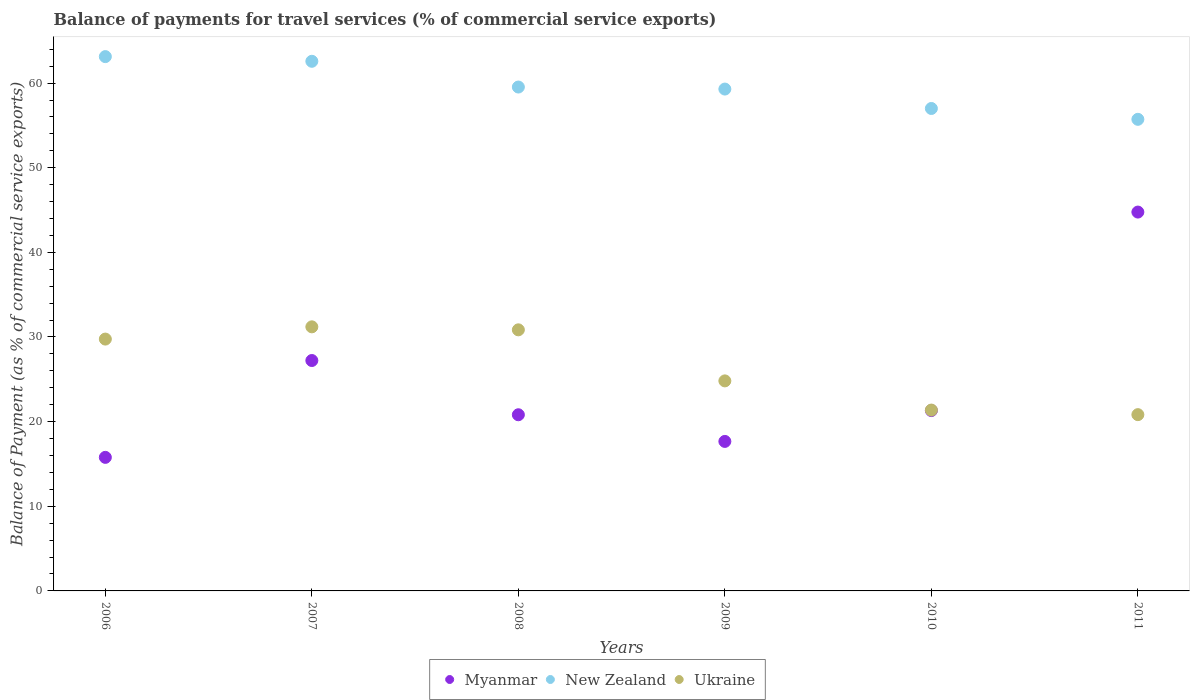Is the number of dotlines equal to the number of legend labels?
Offer a very short reply. Yes. What is the balance of payments for travel services in Myanmar in 2009?
Provide a short and direct response. 17.66. Across all years, what is the maximum balance of payments for travel services in New Zealand?
Provide a short and direct response. 63.13. Across all years, what is the minimum balance of payments for travel services in New Zealand?
Provide a succinct answer. 55.72. In which year was the balance of payments for travel services in Ukraine maximum?
Offer a terse response. 2007. In which year was the balance of payments for travel services in Myanmar minimum?
Provide a succinct answer. 2006. What is the total balance of payments for travel services in Ukraine in the graph?
Provide a short and direct response. 158.81. What is the difference between the balance of payments for travel services in Ukraine in 2007 and that in 2011?
Your answer should be compact. 10.37. What is the difference between the balance of payments for travel services in New Zealand in 2011 and the balance of payments for travel services in Myanmar in 2009?
Offer a terse response. 38.05. What is the average balance of payments for travel services in New Zealand per year?
Keep it short and to the point. 59.54. In the year 2008, what is the difference between the balance of payments for travel services in Ukraine and balance of payments for travel services in New Zealand?
Your response must be concise. -28.69. What is the ratio of the balance of payments for travel services in Myanmar in 2006 to that in 2010?
Your answer should be very brief. 0.74. Is the balance of payments for travel services in Myanmar in 2008 less than that in 2009?
Offer a very short reply. No. What is the difference between the highest and the second highest balance of payments for travel services in New Zealand?
Provide a succinct answer. 0.55. What is the difference between the highest and the lowest balance of payments for travel services in New Zealand?
Your response must be concise. 7.41. In how many years, is the balance of payments for travel services in Ukraine greater than the average balance of payments for travel services in Ukraine taken over all years?
Provide a short and direct response. 3. Is the sum of the balance of payments for travel services in Myanmar in 2008 and 2010 greater than the maximum balance of payments for travel services in Ukraine across all years?
Ensure brevity in your answer.  Yes. Is it the case that in every year, the sum of the balance of payments for travel services in Myanmar and balance of payments for travel services in New Zealand  is greater than the balance of payments for travel services in Ukraine?
Give a very brief answer. Yes. Does the balance of payments for travel services in Ukraine monotonically increase over the years?
Offer a terse response. No. Is the balance of payments for travel services in Myanmar strictly greater than the balance of payments for travel services in Ukraine over the years?
Ensure brevity in your answer.  No. How many dotlines are there?
Your response must be concise. 3. Does the graph contain any zero values?
Keep it short and to the point. No. Does the graph contain grids?
Offer a very short reply. No. Where does the legend appear in the graph?
Make the answer very short. Bottom center. How are the legend labels stacked?
Ensure brevity in your answer.  Horizontal. What is the title of the graph?
Make the answer very short. Balance of payments for travel services (% of commercial service exports). What is the label or title of the X-axis?
Provide a short and direct response. Years. What is the label or title of the Y-axis?
Ensure brevity in your answer.  Balance of Payment (as % of commercial service exports). What is the Balance of Payment (as % of commercial service exports) of Myanmar in 2006?
Keep it short and to the point. 15.78. What is the Balance of Payment (as % of commercial service exports) in New Zealand in 2006?
Provide a succinct answer. 63.13. What is the Balance of Payment (as % of commercial service exports) of Ukraine in 2006?
Provide a short and direct response. 29.75. What is the Balance of Payment (as % of commercial service exports) in Myanmar in 2007?
Provide a succinct answer. 27.22. What is the Balance of Payment (as % of commercial service exports) in New Zealand in 2007?
Your answer should be compact. 62.57. What is the Balance of Payment (as % of commercial service exports) of Ukraine in 2007?
Your answer should be very brief. 31.2. What is the Balance of Payment (as % of commercial service exports) of Myanmar in 2008?
Give a very brief answer. 20.81. What is the Balance of Payment (as % of commercial service exports) of New Zealand in 2008?
Offer a terse response. 59.53. What is the Balance of Payment (as % of commercial service exports) in Ukraine in 2008?
Your answer should be very brief. 30.85. What is the Balance of Payment (as % of commercial service exports) in Myanmar in 2009?
Make the answer very short. 17.66. What is the Balance of Payment (as % of commercial service exports) in New Zealand in 2009?
Provide a short and direct response. 59.29. What is the Balance of Payment (as % of commercial service exports) of Ukraine in 2009?
Your response must be concise. 24.81. What is the Balance of Payment (as % of commercial service exports) in Myanmar in 2010?
Ensure brevity in your answer.  21.31. What is the Balance of Payment (as % of commercial service exports) of New Zealand in 2010?
Offer a very short reply. 57. What is the Balance of Payment (as % of commercial service exports) of Ukraine in 2010?
Ensure brevity in your answer.  21.37. What is the Balance of Payment (as % of commercial service exports) in Myanmar in 2011?
Ensure brevity in your answer.  44.76. What is the Balance of Payment (as % of commercial service exports) in New Zealand in 2011?
Your response must be concise. 55.72. What is the Balance of Payment (as % of commercial service exports) of Ukraine in 2011?
Provide a short and direct response. 20.83. Across all years, what is the maximum Balance of Payment (as % of commercial service exports) of Myanmar?
Provide a succinct answer. 44.76. Across all years, what is the maximum Balance of Payment (as % of commercial service exports) of New Zealand?
Your answer should be very brief. 63.13. Across all years, what is the maximum Balance of Payment (as % of commercial service exports) in Ukraine?
Offer a very short reply. 31.2. Across all years, what is the minimum Balance of Payment (as % of commercial service exports) in Myanmar?
Your response must be concise. 15.78. Across all years, what is the minimum Balance of Payment (as % of commercial service exports) of New Zealand?
Provide a short and direct response. 55.72. Across all years, what is the minimum Balance of Payment (as % of commercial service exports) of Ukraine?
Provide a succinct answer. 20.83. What is the total Balance of Payment (as % of commercial service exports) of Myanmar in the graph?
Give a very brief answer. 147.54. What is the total Balance of Payment (as % of commercial service exports) in New Zealand in the graph?
Give a very brief answer. 357.24. What is the total Balance of Payment (as % of commercial service exports) in Ukraine in the graph?
Ensure brevity in your answer.  158.81. What is the difference between the Balance of Payment (as % of commercial service exports) in Myanmar in 2006 and that in 2007?
Your answer should be very brief. -11.44. What is the difference between the Balance of Payment (as % of commercial service exports) in New Zealand in 2006 and that in 2007?
Your response must be concise. 0.55. What is the difference between the Balance of Payment (as % of commercial service exports) of Ukraine in 2006 and that in 2007?
Your answer should be compact. -1.45. What is the difference between the Balance of Payment (as % of commercial service exports) in Myanmar in 2006 and that in 2008?
Your response must be concise. -5.03. What is the difference between the Balance of Payment (as % of commercial service exports) in New Zealand in 2006 and that in 2008?
Give a very brief answer. 3.59. What is the difference between the Balance of Payment (as % of commercial service exports) of Ukraine in 2006 and that in 2008?
Ensure brevity in your answer.  -1.09. What is the difference between the Balance of Payment (as % of commercial service exports) in Myanmar in 2006 and that in 2009?
Offer a terse response. -1.88. What is the difference between the Balance of Payment (as % of commercial service exports) of New Zealand in 2006 and that in 2009?
Ensure brevity in your answer.  3.83. What is the difference between the Balance of Payment (as % of commercial service exports) of Ukraine in 2006 and that in 2009?
Ensure brevity in your answer.  4.94. What is the difference between the Balance of Payment (as % of commercial service exports) of Myanmar in 2006 and that in 2010?
Give a very brief answer. -5.53. What is the difference between the Balance of Payment (as % of commercial service exports) of New Zealand in 2006 and that in 2010?
Keep it short and to the point. 6.13. What is the difference between the Balance of Payment (as % of commercial service exports) in Ukraine in 2006 and that in 2010?
Provide a succinct answer. 8.39. What is the difference between the Balance of Payment (as % of commercial service exports) in Myanmar in 2006 and that in 2011?
Ensure brevity in your answer.  -28.98. What is the difference between the Balance of Payment (as % of commercial service exports) in New Zealand in 2006 and that in 2011?
Give a very brief answer. 7.41. What is the difference between the Balance of Payment (as % of commercial service exports) in Ukraine in 2006 and that in 2011?
Your answer should be compact. 8.93. What is the difference between the Balance of Payment (as % of commercial service exports) of Myanmar in 2007 and that in 2008?
Give a very brief answer. 6.41. What is the difference between the Balance of Payment (as % of commercial service exports) in New Zealand in 2007 and that in 2008?
Your answer should be compact. 3.04. What is the difference between the Balance of Payment (as % of commercial service exports) of Ukraine in 2007 and that in 2008?
Offer a terse response. 0.35. What is the difference between the Balance of Payment (as % of commercial service exports) of Myanmar in 2007 and that in 2009?
Give a very brief answer. 9.56. What is the difference between the Balance of Payment (as % of commercial service exports) in New Zealand in 2007 and that in 2009?
Make the answer very short. 3.28. What is the difference between the Balance of Payment (as % of commercial service exports) in Ukraine in 2007 and that in 2009?
Offer a terse response. 6.39. What is the difference between the Balance of Payment (as % of commercial service exports) of Myanmar in 2007 and that in 2010?
Offer a very short reply. 5.91. What is the difference between the Balance of Payment (as % of commercial service exports) in New Zealand in 2007 and that in 2010?
Make the answer very short. 5.57. What is the difference between the Balance of Payment (as % of commercial service exports) in Ukraine in 2007 and that in 2010?
Offer a terse response. 9.83. What is the difference between the Balance of Payment (as % of commercial service exports) in Myanmar in 2007 and that in 2011?
Your answer should be compact. -17.54. What is the difference between the Balance of Payment (as % of commercial service exports) in New Zealand in 2007 and that in 2011?
Your answer should be compact. 6.86. What is the difference between the Balance of Payment (as % of commercial service exports) in Ukraine in 2007 and that in 2011?
Offer a terse response. 10.37. What is the difference between the Balance of Payment (as % of commercial service exports) of Myanmar in 2008 and that in 2009?
Your answer should be compact. 3.15. What is the difference between the Balance of Payment (as % of commercial service exports) in New Zealand in 2008 and that in 2009?
Offer a very short reply. 0.24. What is the difference between the Balance of Payment (as % of commercial service exports) of Ukraine in 2008 and that in 2009?
Offer a terse response. 6.03. What is the difference between the Balance of Payment (as % of commercial service exports) of Myanmar in 2008 and that in 2010?
Give a very brief answer. -0.49. What is the difference between the Balance of Payment (as % of commercial service exports) in New Zealand in 2008 and that in 2010?
Offer a very short reply. 2.53. What is the difference between the Balance of Payment (as % of commercial service exports) of Ukraine in 2008 and that in 2010?
Your answer should be very brief. 9.48. What is the difference between the Balance of Payment (as % of commercial service exports) in Myanmar in 2008 and that in 2011?
Keep it short and to the point. -23.95. What is the difference between the Balance of Payment (as % of commercial service exports) in New Zealand in 2008 and that in 2011?
Give a very brief answer. 3.81. What is the difference between the Balance of Payment (as % of commercial service exports) of Ukraine in 2008 and that in 2011?
Provide a short and direct response. 10.02. What is the difference between the Balance of Payment (as % of commercial service exports) of Myanmar in 2009 and that in 2010?
Provide a succinct answer. -3.64. What is the difference between the Balance of Payment (as % of commercial service exports) in New Zealand in 2009 and that in 2010?
Your answer should be very brief. 2.29. What is the difference between the Balance of Payment (as % of commercial service exports) in Ukraine in 2009 and that in 2010?
Provide a short and direct response. 3.45. What is the difference between the Balance of Payment (as % of commercial service exports) in Myanmar in 2009 and that in 2011?
Offer a terse response. -27.1. What is the difference between the Balance of Payment (as % of commercial service exports) in New Zealand in 2009 and that in 2011?
Offer a terse response. 3.58. What is the difference between the Balance of Payment (as % of commercial service exports) of Ukraine in 2009 and that in 2011?
Provide a short and direct response. 3.99. What is the difference between the Balance of Payment (as % of commercial service exports) of Myanmar in 2010 and that in 2011?
Provide a succinct answer. -23.45. What is the difference between the Balance of Payment (as % of commercial service exports) of New Zealand in 2010 and that in 2011?
Keep it short and to the point. 1.28. What is the difference between the Balance of Payment (as % of commercial service exports) in Ukraine in 2010 and that in 2011?
Make the answer very short. 0.54. What is the difference between the Balance of Payment (as % of commercial service exports) in Myanmar in 2006 and the Balance of Payment (as % of commercial service exports) in New Zealand in 2007?
Your response must be concise. -46.79. What is the difference between the Balance of Payment (as % of commercial service exports) of Myanmar in 2006 and the Balance of Payment (as % of commercial service exports) of Ukraine in 2007?
Your response must be concise. -15.42. What is the difference between the Balance of Payment (as % of commercial service exports) of New Zealand in 2006 and the Balance of Payment (as % of commercial service exports) of Ukraine in 2007?
Provide a succinct answer. 31.93. What is the difference between the Balance of Payment (as % of commercial service exports) of Myanmar in 2006 and the Balance of Payment (as % of commercial service exports) of New Zealand in 2008?
Give a very brief answer. -43.75. What is the difference between the Balance of Payment (as % of commercial service exports) in Myanmar in 2006 and the Balance of Payment (as % of commercial service exports) in Ukraine in 2008?
Your answer should be very brief. -15.07. What is the difference between the Balance of Payment (as % of commercial service exports) in New Zealand in 2006 and the Balance of Payment (as % of commercial service exports) in Ukraine in 2008?
Provide a short and direct response. 32.28. What is the difference between the Balance of Payment (as % of commercial service exports) in Myanmar in 2006 and the Balance of Payment (as % of commercial service exports) in New Zealand in 2009?
Keep it short and to the point. -43.51. What is the difference between the Balance of Payment (as % of commercial service exports) of Myanmar in 2006 and the Balance of Payment (as % of commercial service exports) of Ukraine in 2009?
Give a very brief answer. -9.04. What is the difference between the Balance of Payment (as % of commercial service exports) in New Zealand in 2006 and the Balance of Payment (as % of commercial service exports) in Ukraine in 2009?
Offer a terse response. 38.31. What is the difference between the Balance of Payment (as % of commercial service exports) of Myanmar in 2006 and the Balance of Payment (as % of commercial service exports) of New Zealand in 2010?
Offer a very short reply. -41.22. What is the difference between the Balance of Payment (as % of commercial service exports) in Myanmar in 2006 and the Balance of Payment (as % of commercial service exports) in Ukraine in 2010?
Your answer should be very brief. -5.59. What is the difference between the Balance of Payment (as % of commercial service exports) in New Zealand in 2006 and the Balance of Payment (as % of commercial service exports) in Ukraine in 2010?
Your response must be concise. 41.76. What is the difference between the Balance of Payment (as % of commercial service exports) in Myanmar in 2006 and the Balance of Payment (as % of commercial service exports) in New Zealand in 2011?
Give a very brief answer. -39.94. What is the difference between the Balance of Payment (as % of commercial service exports) of Myanmar in 2006 and the Balance of Payment (as % of commercial service exports) of Ukraine in 2011?
Your answer should be very brief. -5.05. What is the difference between the Balance of Payment (as % of commercial service exports) in New Zealand in 2006 and the Balance of Payment (as % of commercial service exports) in Ukraine in 2011?
Your answer should be compact. 42.3. What is the difference between the Balance of Payment (as % of commercial service exports) of Myanmar in 2007 and the Balance of Payment (as % of commercial service exports) of New Zealand in 2008?
Offer a terse response. -32.31. What is the difference between the Balance of Payment (as % of commercial service exports) in Myanmar in 2007 and the Balance of Payment (as % of commercial service exports) in Ukraine in 2008?
Your response must be concise. -3.63. What is the difference between the Balance of Payment (as % of commercial service exports) of New Zealand in 2007 and the Balance of Payment (as % of commercial service exports) of Ukraine in 2008?
Provide a succinct answer. 31.73. What is the difference between the Balance of Payment (as % of commercial service exports) in Myanmar in 2007 and the Balance of Payment (as % of commercial service exports) in New Zealand in 2009?
Your answer should be compact. -32.07. What is the difference between the Balance of Payment (as % of commercial service exports) of Myanmar in 2007 and the Balance of Payment (as % of commercial service exports) of Ukraine in 2009?
Offer a very short reply. 2.41. What is the difference between the Balance of Payment (as % of commercial service exports) of New Zealand in 2007 and the Balance of Payment (as % of commercial service exports) of Ukraine in 2009?
Provide a succinct answer. 37.76. What is the difference between the Balance of Payment (as % of commercial service exports) of Myanmar in 2007 and the Balance of Payment (as % of commercial service exports) of New Zealand in 2010?
Provide a short and direct response. -29.78. What is the difference between the Balance of Payment (as % of commercial service exports) in Myanmar in 2007 and the Balance of Payment (as % of commercial service exports) in Ukraine in 2010?
Offer a terse response. 5.86. What is the difference between the Balance of Payment (as % of commercial service exports) of New Zealand in 2007 and the Balance of Payment (as % of commercial service exports) of Ukraine in 2010?
Your response must be concise. 41.21. What is the difference between the Balance of Payment (as % of commercial service exports) of Myanmar in 2007 and the Balance of Payment (as % of commercial service exports) of New Zealand in 2011?
Give a very brief answer. -28.5. What is the difference between the Balance of Payment (as % of commercial service exports) of Myanmar in 2007 and the Balance of Payment (as % of commercial service exports) of Ukraine in 2011?
Ensure brevity in your answer.  6.39. What is the difference between the Balance of Payment (as % of commercial service exports) in New Zealand in 2007 and the Balance of Payment (as % of commercial service exports) in Ukraine in 2011?
Make the answer very short. 41.75. What is the difference between the Balance of Payment (as % of commercial service exports) in Myanmar in 2008 and the Balance of Payment (as % of commercial service exports) in New Zealand in 2009?
Your response must be concise. -38.48. What is the difference between the Balance of Payment (as % of commercial service exports) of Myanmar in 2008 and the Balance of Payment (as % of commercial service exports) of Ukraine in 2009?
Give a very brief answer. -4. What is the difference between the Balance of Payment (as % of commercial service exports) of New Zealand in 2008 and the Balance of Payment (as % of commercial service exports) of Ukraine in 2009?
Keep it short and to the point. 34.72. What is the difference between the Balance of Payment (as % of commercial service exports) of Myanmar in 2008 and the Balance of Payment (as % of commercial service exports) of New Zealand in 2010?
Give a very brief answer. -36.18. What is the difference between the Balance of Payment (as % of commercial service exports) of Myanmar in 2008 and the Balance of Payment (as % of commercial service exports) of Ukraine in 2010?
Give a very brief answer. -0.55. What is the difference between the Balance of Payment (as % of commercial service exports) of New Zealand in 2008 and the Balance of Payment (as % of commercial service exports) of Ukraine in 2010?
Your response must be concise. 38.17. What is the difference between the Balance of Payment (as % of commercial service exports) in Myanmar in 2008 and the Balance of Payment (as % of commercial service exports) in New Zealand in 2011?
Offer a terse response. -34.9. What is the difference between the Balance of Payment (as % of commercial service exports) in Myanmar in 2008 and the Balance of Payment (as % of commercial service exports) in Ukraine in 2011?
Provide a succinct answer. -0.01. What is the difference between the Balance of Payment (as % of commercial service exports) in New Zealand in 2008 and the Balance of Payment (as % of commercial service exports) in Ukraine in 2011?
Your answer should be compact. 38.71. What is the difference between the Balance of Payment (as % of commercial service exports) of Myanmar in 2009 and the Balance of Payment (as % of commercial service exports) of New Zealand in 2010?
Your answer should be compact. -39.33. What is the difference between the Balance of Payment (as % of commercial service exports) of Myanmar in 2009 and the Balance of Payment (as % of commercial service exports) of Ukraine in 2010?
Provide a succinct answer. -3.7. What is the difference between the Balance of Payment (as % of commercial service exports) in New Zealand in 2009 and the Balance of Payment (as % of commercial service exports) in Ukraine in 2010?
Provide a short and direct response. 37.93. What is the difference between the Balance of Payment (as % of commercial service exports) of Myanmar in 2009 and the Balance of Payment (as % of commercial service exports) of New Zealand in 2011?
Provide a short and direct response. -38.05. What is the difference between the Balance of Payment (as % of commercial service exports) in Myanmar in 2009 and the Balance of Payment (as % of commercial service exports) in Ukraine in 2011?
Your answer should be very brief. -3.16. What is the difference between the Balance of Payment (as % of commercial service exports) in New Zealand in 2009 and the Balance of Payment (as % of commercial service exports) in Ukraine in 2011?
Ensure brevity in your answer.  38.47. What is the difference between the Balance of Payment (as % of commercial service exports) in Myanmar in 2010 and the Balance of Payment (as % of commercial service exports) in New Zealand in 2011?
Your response must be concise. -34.41. What is the difference between the Balance of Payment (as % of commercial service exports) in Myanmar in 2010 and the Balance of Payment (as % of commercial service exports) in Ukraine in 2011?
Your answer should be very brief. 0.48. What is the difference between the Balance of Payment (as % of commercial service exports) of New Zealand in 2010 and the Balance of Payment (as % of commercial service exports) of Ukraine in 2011?
Make the answer very short. 36.17. What is the average Balance of Payment (as % of commercial service exports) of Myanmar per year?
Make the answer very short. 24.59. What is the average Balance of Payment (as % of commercial service exports) of New Zealand per year?
Keep it short and to the point. 59.54. What is the average Balance of Payment (as % of commercial service exports) of Ukraine per year?
Offer a terse response. 26.47. In the year 2006, what is the difference between the Balance of Payment (as % of commercial service exports) in Myanmar and Balance of Payment (as % of commercial service exports) in New Zealand?
Keep it short and to the point. -47.35. In the year 2006, what is the difference between the Balance of Payment (as % of commercial service exports) of Myanmar and Balance of Payment (as % of commercial service exports) of Ukraine?
Give a very brief answer. -13.97. In the year 2006, what is the difference between the Balance of Payment (as % of commercial service exports) in New Zealand and Balance of Payment (as % of commercial service exports) in Ukraine?
Your answer should be compact. 33.37. In the year 2007, what is the difference between the Balance of Payment (as % of commercial service exports) of Myanmar and Balance of Payment (as % of commercial service exports) of New Zealand?
Your response must be concise. -35.35. In the year 2007, what is the difference between the Balance of Payment (as % of commercial service exports) in Myanmar and Balance of Payment (as % of commercial service exports) in Ukraine?
Offer a terse response. -3.98. In the year 2007, what is the difference between the Balance of Payment (as % of commercial service exports) of New Zealand and Balance of Payment (as % of commercial service exports) of Ukraine?
Make the answer very short. 31.37. In the year 2008, what is the difference between the Balance of Payment (as % of commercial service exports) of Myanmar and Balance of Payment (as % of commercial service exports) of New Zealand?
Give a very brief answer. -38.72. In the year 2008, what is the difference between the Balance of Payment (as % of commercial service exports) in Myanmar and Balance of Payment (as % of commercial service exports) in Ukraine?
Provide a succinct answer. -10.03. In the year 2008, what is the difference between the Balance of Payment (as % of commercial service exports) of New Zealand and Balance of Payment (as % of commercial service exports) of Ukraine?
Your answer should be compact. 28.69. In the year 2009, what is the difference between the Balance of Payment (as % of commercial service exports) of Myanmar and Balance of Payment (as % of commercial service exports) of New Zealand?
Give a very brief answer. -41.63. In the year 2009, what is the difference between the Balance of Payment (as % of commercial service exports) in Myanmar and Balance of Payment (as % of commercial service exports) in Ukraine?
Offer a terse response. -7.15. In the year 2009, what is the difference between the Balance of Payment (as % of commercial service exports) of New Zealand and Balance of Payment (as % of commercial service exports) of Ukraine?
Provide a short and direct response. 34.48. In the year 2010, what is the difference between the Balance of Payment (as % of commercial service exports) of Myanmar and Balance of Payment (as % of commercial service exports) of New Zealand?
Your answer should be compact. -35.69. In the year 2010, what is the difference between the Balance of Payment (as % of commercial service exports) in Myanmar and Balance of Payment (as % of commercial service exports) in Ukraine?
Ensure brevity in your answer.  -0.06. In the year 2010, what is the difference between the Balance of Payment (as % of commercial service exports) in New Zealand and Balance of Payment (as % of commercial service exports) in Ukraine?
Offer a very short reply. 35.63. In the year 2011, what is the difference between the Balance of Payment (as % of commercial service exports) in Myanmar and Balance of Payment (as % of commercial service exports) in New Zealand?
Provide a short and direct response. -10.96. In the year 2011, what is the difference between the Balance of Payment (as % of commercial service exports) of Myanmar and Balance of Payment (as % of commercial service exports) of Ukraine?
Offer a terse response. 23.93. In the year 2011, what is the difference between the Balance of Payment (as % of commercial service exports) in New Zealand and Balance of Payment (as % of commercial service exports) in Ukraine?
Your response must be concise. 34.89. What is the ratio of the Balance of Payment (as % of commercial service exports) of Myanmar in 2006 to that in 2007?
Keep it short and to the point. 0.58. What is the ratio of the Balance of Payment (as % of commercial service exports) in New Zealand in 2006 to that in 2007?
Provide a succinct answer. 1.01. What is the ratio of the Balance of Payment (as % of commercial service exports) of Ukraine in 2006 to that in 2007?
Make the answer very short. 0.95. What is the ratio of the Balance of Payment (as % of commercial service exports) of Myanmar in 2006 to that in 2008?
Your answer should be very brief. 0.76. What is the ratio of the Balance of Payment (as % of commercial service exports) in New Zealand in 2006 to that in 2008?
Your answer should be very brief. 1.06. What is the ratio of the Balance of Payment (as % of commercial service exports) in Ukraine in 2006 to that in 2008?
Provide a short and direct response. 0.96. What is the ratio of the Balance of Payment (as % of commercial service exports) of Myanmar in 2006 to that in 2009?
Give a very brief answer. 0.89. What is the ratio of the Balance of Payment (as % of commercial service exports) in New Zealand in 2006 to that in 2009?
Your answer should be very brief. 1.06. What is the ratio of the Balance of Payment (as % of commercial service exports) of Ukraine in 2006 to that in 2009?
Provide a short and direct response. 1.2. What is the ratio of the Balance of Payment (as % of commercial service exports) of Myanmar in 2006 to that in 2010?
Provide a succinct answer. 0.74. What is the ratio of the Balance of Payment (as % of commercial service exports) of New Zealand in 2006 to that in 2010?
Your answer should be compact. 1.11. What is the ratio of the Balance of Payment (as % of commercial service exports) in Ukraine in 2006 to that in 2010?
Make the answer very short. 1.39. What is the ratio of the Balance of Payment (as % of commercial service exports) of Myanmar in 2006 to that in 2011?
Keep it short and to the point. 0.35. What is the ratio of the Balance of Payment (as % of commercial service exports) in New Zealand in 2006 to that in 2011?
Provide a short and direct response. 1.13. What is the ratio of the Balance of Payment (as % of commercial service exports) of Ukraine in 2006 to that in 2011?
Make the answer very short. 1.43. What is the ratio of the Balance of Payment (as % of commercial service exports) of Myanmar in 2007 to that in 2008?
Provide a short and direct response. 1.31. What is the ratio of the Balance of Payment (as % of commercial service exports) in New Zealand in 2007 to that in 2008?
Offer a terse response. 1.05. What is the ratio of the Balance of Payment (as % of commercial service exports) in Ukraine in 2007 to that in 2008?
Keep it short and to the point. 1.01. What is the ratio of the Balance of Payment (as % of commercial service exports) in Myanmar in 2007 to that in 2009?
Offer a very short reply. 1.54. What is the ratio of the Balance of Payment (as % of commercial service exports) in New Zealand in 2007 to that in 2009?
Give a very brief answer. 1.06. What is the ratio of the Balance of Payment (as % of commercial service exports) in Ukraine in 2007 to that in 2009?
Your response must be concise. 1.26. What is the ratio of the Balance of Payment (as % of commercial service exports) of Myanmar in 2007 to that in 2010?
Give a very brief answer. 1.28. What is the ratio of the Balance of Payment (as % of commercial service exports) of New Zealand in 2007 to that in 2010?
Provide a succinct answer. 1.1. What is the ratio of the Balance of Payment (as % of commercial service exports) of Ukraine in 2007 to that in 2010?
Offer a terse response. 1.46. What is the ratio of the Balance of Payment (as % of commercial service exports) of Myanmar in 2007 to that in 2011?
Your answer should be compact. 0.61. What is the ratio of the Balance of Payment (as % of commercial service exports) of New Zealand in 2007 to that in 2011?
Give a very brief answer. 1.12. What is the ratio of the Balance of Payment (as % of commercial service exports) of Ukraine in 2007 to that in 2011?
Offer a very short reply. 1.5. What is the ratio of the Balance of Payment (as % of commercial service exports) of Myanmar in 2008 to that in 2009?
Your answer should be compact. 1.18. What is the ratio of the Balance of Payment (as % of commercial service exports) of Ukraine in 2008 to that in 2009?
Your response must be concise. 1.24. What is the ratio of the Balance of Payment (as % of commercial service exports) of Myanmar in 2008 to that in 2010?
Offer a very short reply. 0.98. What is the ratio of the Balance of Payment (as % of commercial service exports) of New Zealand in 2008 to that in 2010?
Provide a short and direct response. 1.04. What is the ratio of the Balance of Payment (as % of commercial service exports) of Ukraine in 2008 to that in 2010?
Offer a very short reply. 1.44. What is the ratio of the Balance of Payment (as % of commercial service exports) in Myanmar in 2008 to that in 2011?
Provide a succinct answer. 0.47. What is the ratio of the Balance of Payment (as % of commercial service exports) of New Zealand in 2008 to that in 2011?
Your response must be concise. 1.07. What is the ratio of the Balance of Payment (as % of commercial service exports) of Ukraine in 2008 to that in 2011?
Provide a short and direct response. 1.48. What is the ratio of the Balance of Payment (as % of commercial service exports) of Myanmar in 2009 to that in 2010?
Offer a terse response. 0.83. What is the ratio of the Balance of Payment (as % of commercial service exports) in New Zealand in 2009 to that in 2010?
Offer a very short reply. 1.04. What is the ratio of the Balance of Payment (as % of commercial service exports) of Ukraine in 2009 to that in 2010?
Offer a terse response. 1.16. What is the ratio of the Balance of Payment (as % of commercial service exports) in Myanmar in 2009 to that in 2011?
Your answer should be compact. 0.39. What is the ratio of the Balance of Payment (as % of commercial service exports) in New Zealand in 2009 to that in 2011?
Provide a succinct answer. 1.06. What is the ratio of the Balance of Payment (as % of commercial service exports) of Ukraine in 2009 to that in 2011?
Your answer should be compact. 1.19. What is the ratio of the Balance of Payment (as % of commercial service exports) in Myanmar in 2010 to that in 2011?
Give a very brief answer. 0.48. What is the ratio of the Balance of Payment (as % of commercial service exports) in New Zealand in 2010 to that in 2011?
Provide a succinct answer. 1.02. What is the ratio of the Balance of Payment (as % of commercial service exports) of Ukraine in 2010 to that in 2011?
Provide a short and direct response. 1.03. What is the difference between the highest and the second highest Balance of Payment (as % of commercial service exports) of Myanmar?
Give a very brief answer. 17.54. What is the difference between the highest and the second highest Balance of Payment (as % of commercial service exports) of New Zealand?
Provide a succinct answer. 0.55. What is the difference between the highest and the second highest Balance of Payment (as % of commercial service exports) of Ukraine?
Your answer should be compact. 0.35. What is the difference between the highest and the lowest Balance of Payment (as % of commercial service exports) in Myanmar?
Your response must be concise. 28.98. What is the difference between the highest and the lowest Balance of Payment (as % of commercial service exports) of New Zealand?
Provide a short and direct response. 7.41. What is the difference between the highest and the lowest Balance of Payment (as % of commercial service exports) in Ukraine?
Your answer should be very brief. 10.37. 